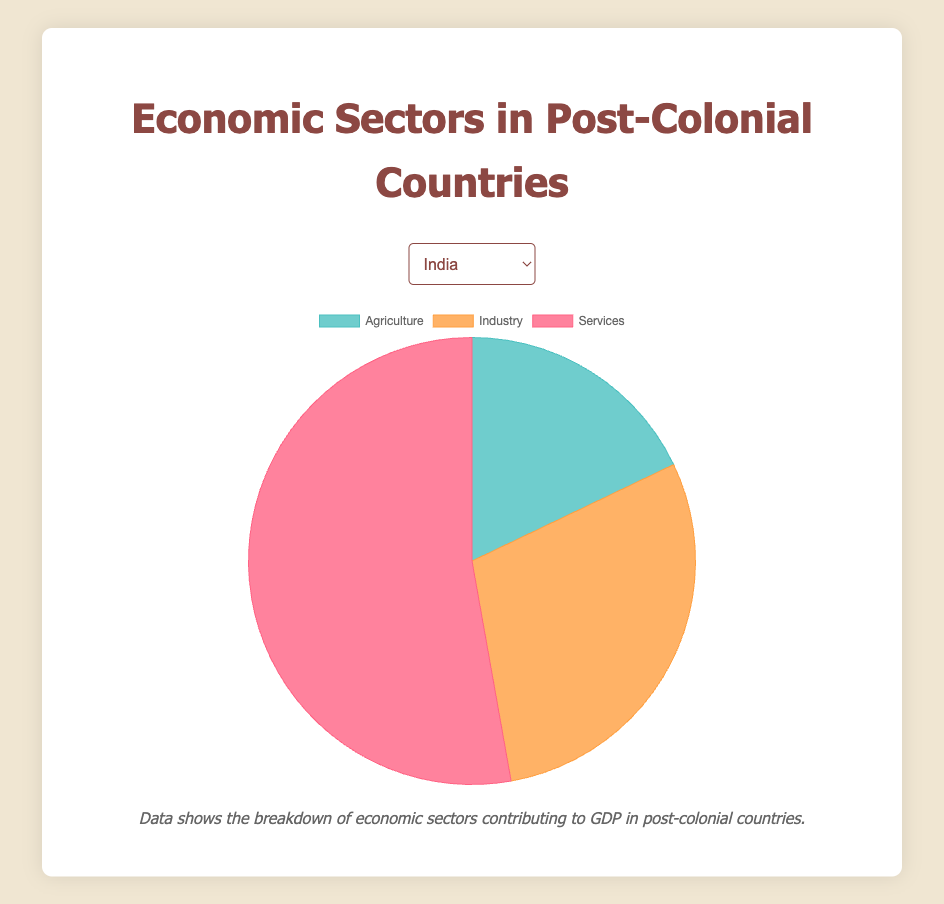Which economic sector contributes the most to India's GDP? From the pie chart for India, the "Services" sector has the largest share, constituting 52.8% of the GDP.
Answer: Services What is the difference in GDP contribution between the Industry and Services sectors in Kenya? From the pie chart for Kenya, the contribution from the "Industry" sector is 17.8% and the "Services" sector is 47.9%. The difference is 47.9% - 17.8% = 30.1%.
Answer: 30.1% Between Nigeria and Algeria, which country has a higher contribution from the Agriculture sector? From the pie chart, Nigeria's Agriculture sector contributes 21.0% while Algeria's Agriculture sector contributes 12.5%, so Nigeria has a higher contribution from the Agriculture sector.
Answer: Nigeria Which country has the smallest Agriculture sector contribution to GDP, and what is the percentage? From the pie charts for all countries, Malaysia has the smallest contribution from the Agriculture sector at 8.8%.
Answer: Malaysia, 8.8% How does the GDP contribution of the Industry sector in Indonesia compare to that in Vietnam? From the pie charts, the Industry sector in Indonesia contributes 41.0% to GDP, while in Vietnam, it contributes 33.7%. Therefore, Indonesia's Industry sector contributes more by 41.0% - 33.7% = 7.3%.
Answer: Indonesia's Industry sector is higher by 7.3% In Ghana, what is the combined percentage contribution of Agriculture and Industry sectors to GDP? From the pie chart for Ghana, the Agriculture sector contributes 18.3% and the Industry sector contributes 24.5%. The combined contribution is 18.3% + 24.5% = 42.8%.
Answer: 42.8% Which country shows the highest contribution from the Services sector, and what is the percentage? From the pie charts for all countries, Senegal has the highest Services sector contribution at 58.4%.
Answer: Senegal, 58.4% For Bangladesh, which economic sector contributes approximately one-third of its GDP? From the pie chart for Bangladesh, the Industry sector contributes 34.6%, which is approximately one-third of the GDP.
Answer: Industry Considering India and Malaysia, in which country does the Services sector contribute more to the GDP, and by how much? From the pie charts, India's Services sector contributes 52.8%, while Malaysia's contributes 53.4%. Thus, Malaysia's Services sector contribution is higher by 53.4% - 52.8% = 0.6%.
Answer: Malaysia, 0.6% 